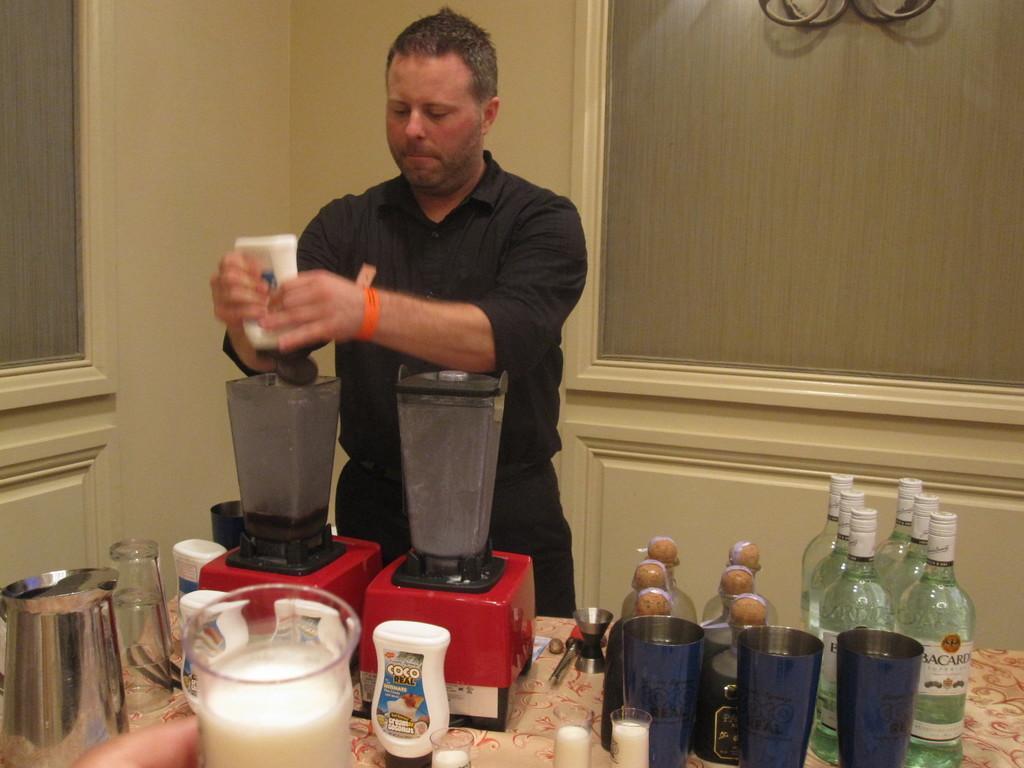Can you describe this image briefly? In this picture we can see man standing and pouring something in this jar and on table we can see bottles, glasses, jar and in background we can see wall. 